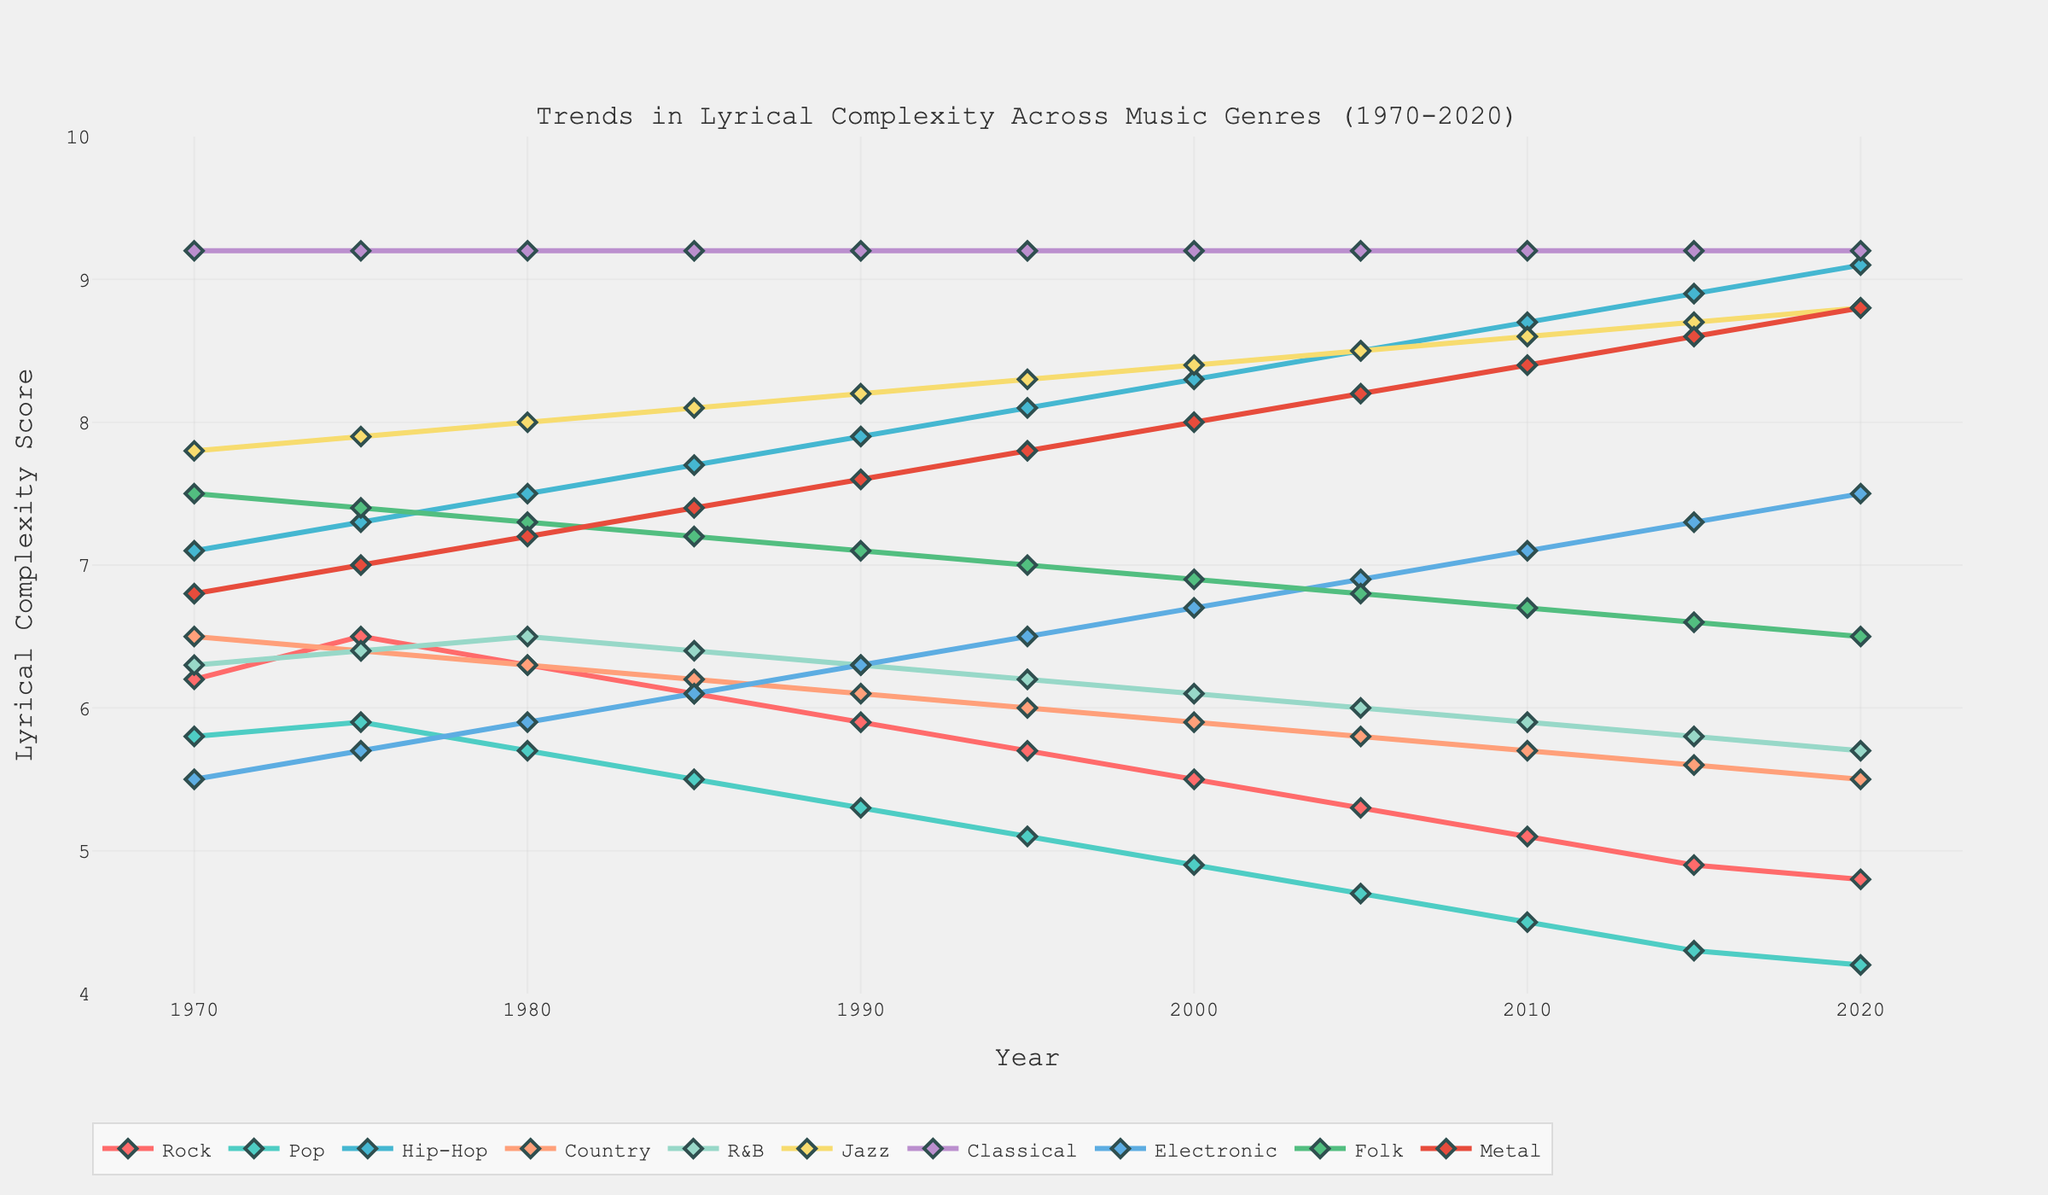What is the trend of lyrical complexity in the Pop genre from 1970 to 2020? The lyrical complexity in Pop shows a steady decline over the years, starting at 5.8 in 1970 and dropping to 4.2 in 2020. This indicates a consistent decrease in lyrical complexity over the 50-year period.
Answer: Steady decline Which genre shows the highest increase in lyrical complexity between 1970 and 2020? To determine the highest increase, compare the differences between the lyrical complexities in 1970 and 2020 for each genre. The Electronic genre has the most significant increase, going from 5.5 in 1970 to 7.5 in 2020, an increase of 2.0 points.
Answer: Electronic Compare the lyrical complexity of Jazz and Metal in 2020. Which genre has a higher score? Observe the y-values for both Jazz and Metal in 2020. Jazz has a lyrical complexity score of 8.8, while Metal has a score of 8.8. Therefore, Jazz and Metal have equal lyrical complexity scores in 2020.
Answer: Equal How does the lyrical complexity of Classical music change over the years? Classical music maintains a constant lyrical complexity score of 9.2 from 1970 to 2020.
Answer: Constant What is the average lyrical complexity of Rock and Country music in 2000? To find the average, add the lyrical complexity scores of Rock (5.5) and Country (5.9) in 2000 and divide by two: (5.5 + 5.9) / 2 = 5.7.
Answer: 5.7 Which genre experienced the most significant decline in lyrical complexity from 1970 to 2020? To determine this, compare the differences between the lyrical complexities in 1970 and 2020 for each genre. Rock shows the most significant decline, going from 6.2 in 1970 to 4.8 in 2020, a decrease of 1.4 points.
Answer: Rock What is the lyrical complexity score difference between Hip-Hop and Folk in 1990? Subtract the lyrical complexity score of Folk (7.1) from that of Hip-Hop (7.9) in 1990: 7.9 - 7.1 = 0.8.
Answer: 0.8 